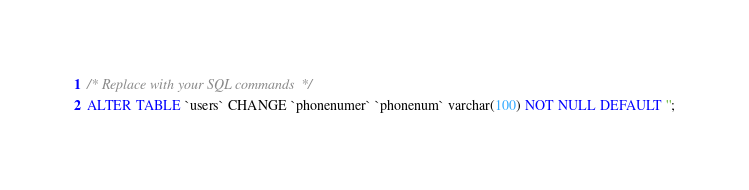<code> <loc_0><loc_0><loc_500><loc_500><_SQL_>/* Replace with your SQL commands */
ALTER TABLE `users` CHANGE `phonenumer` `phonenum` varchar(100) NOT NULL DEFAULT '';</code> 